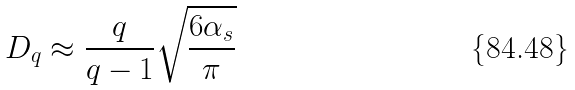<formula> <loc_0><loc_0><loc_500><loc_500>D _ { q } \approx \frac { q } { q - 1 } \sqrt { \frac { 6 \alpha _ { s } } { \pi } }</formula> 